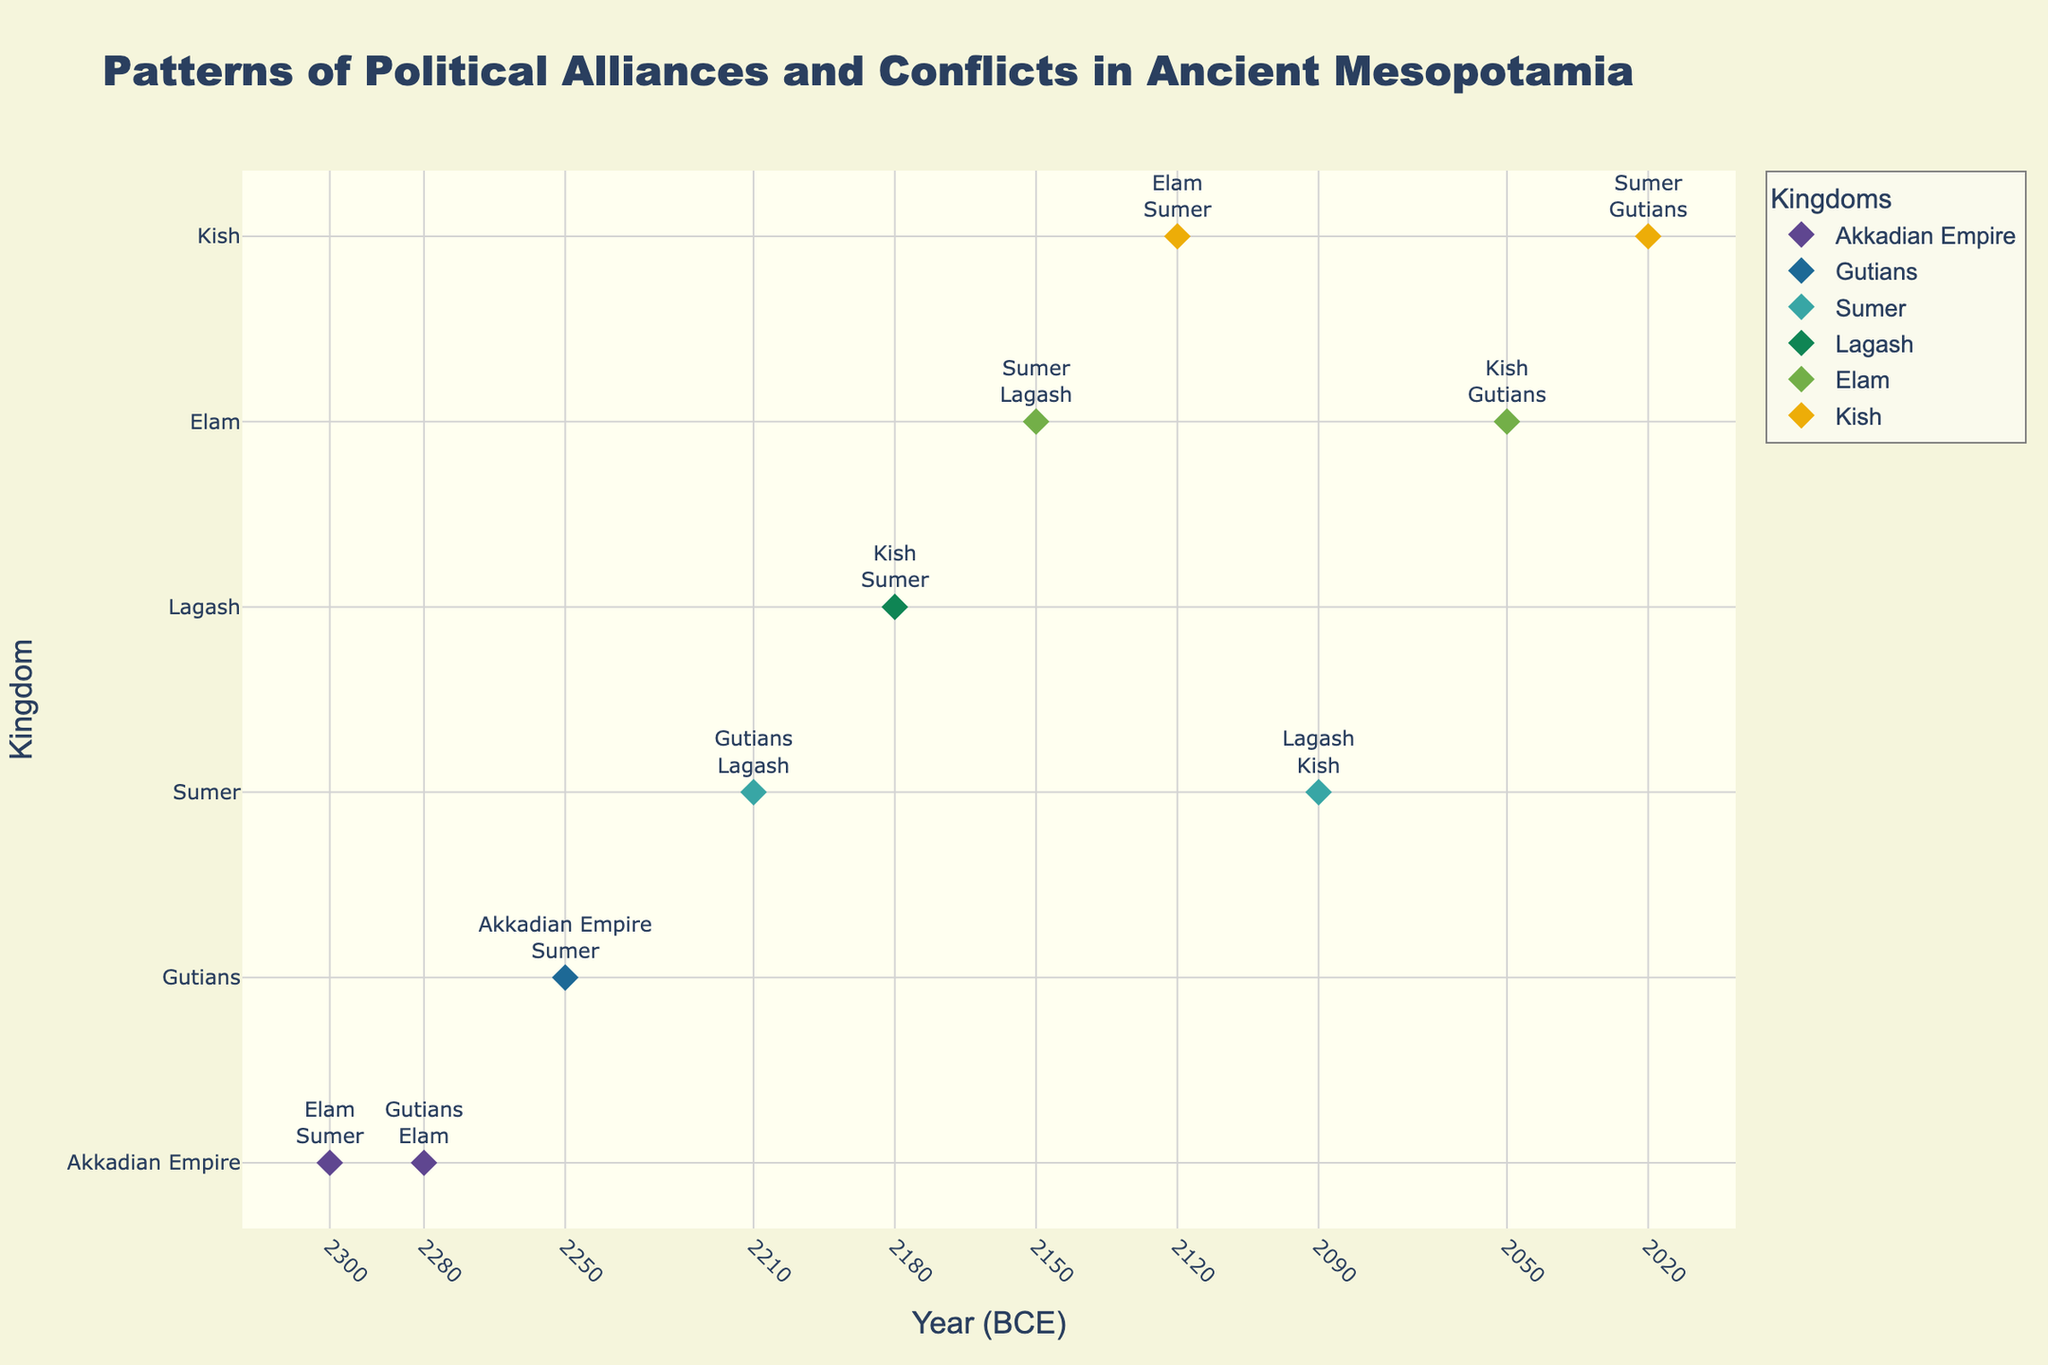What's the title of the figure? The title appears at the top of the figure and is usually the largest text, making it easy to locate.
Answer: Patterns of Political Alliances and Conflicts in Ancient Mesopotamia Which kingdom has the most data points? Count the markers for each kingdom. The kingdom with the most markers has the most data points.
Answer: Sumer What year did Sumer become an ally with the Gutians? Look for the data point where the kingdom is Sumer and the ally is Gutians, and read off the year from the x-axis.
Answer: 2210 BCE How many years did Kish maintain alliances and conflicts between 2120 BCE and 2020 BCE? Count the number of data points for Kish within that year range. There are two data points, 2120 BCE and 2020 BCE.
Answer: 2 Which kingdom was in conflict with Sumer in 2180 BCE? Locate the data point for 2180 BCE and check the kingdom that lists Sumer as their enemy.
Answer: Lagash Between 2250 BCE and 2050 BCE, which kingdom switched from an ally to an enemy relationship with Sumer? Look for a kingdom that was first listed as an ally and then as an enemy within the specified years. Identify the transition from Sumer's ally to its enemy.
Answer: Gutians Compare the frequency of conflicts involving Elam before and after 2150 BCE. Before 2150 BCE, they had conflicts at 2300 BCE and 2280 BCE. After 2150 BCE, they had conflicts at 2120 BCE and 2050 BCE. Which period had more conflicts? Count the number of conflicts involving Elam before and after 2150 BCE. Before: 2, After: 2.
Answer: Same Calculate the total number of kingdoms involved in conflicts in 2050 BCE. Refer to the data point for 2050 BCE, noting the kingdom, its ally, and its enemy. Count the distinct kingdoms involved.
Answer: 3 Which kingdom had recurring conflicts with Sumer across the most years? Scan through all data points where Sumer is an enemy. Tally the years and check which kingdom appears most frequently in these years.
Answer: Kish When did Lagash have an alliance with Kish? Find the data point where the kingdom is Lagash and the ally is Kish, and read off the year from the x-axis.
Answer: 2180 BCE 